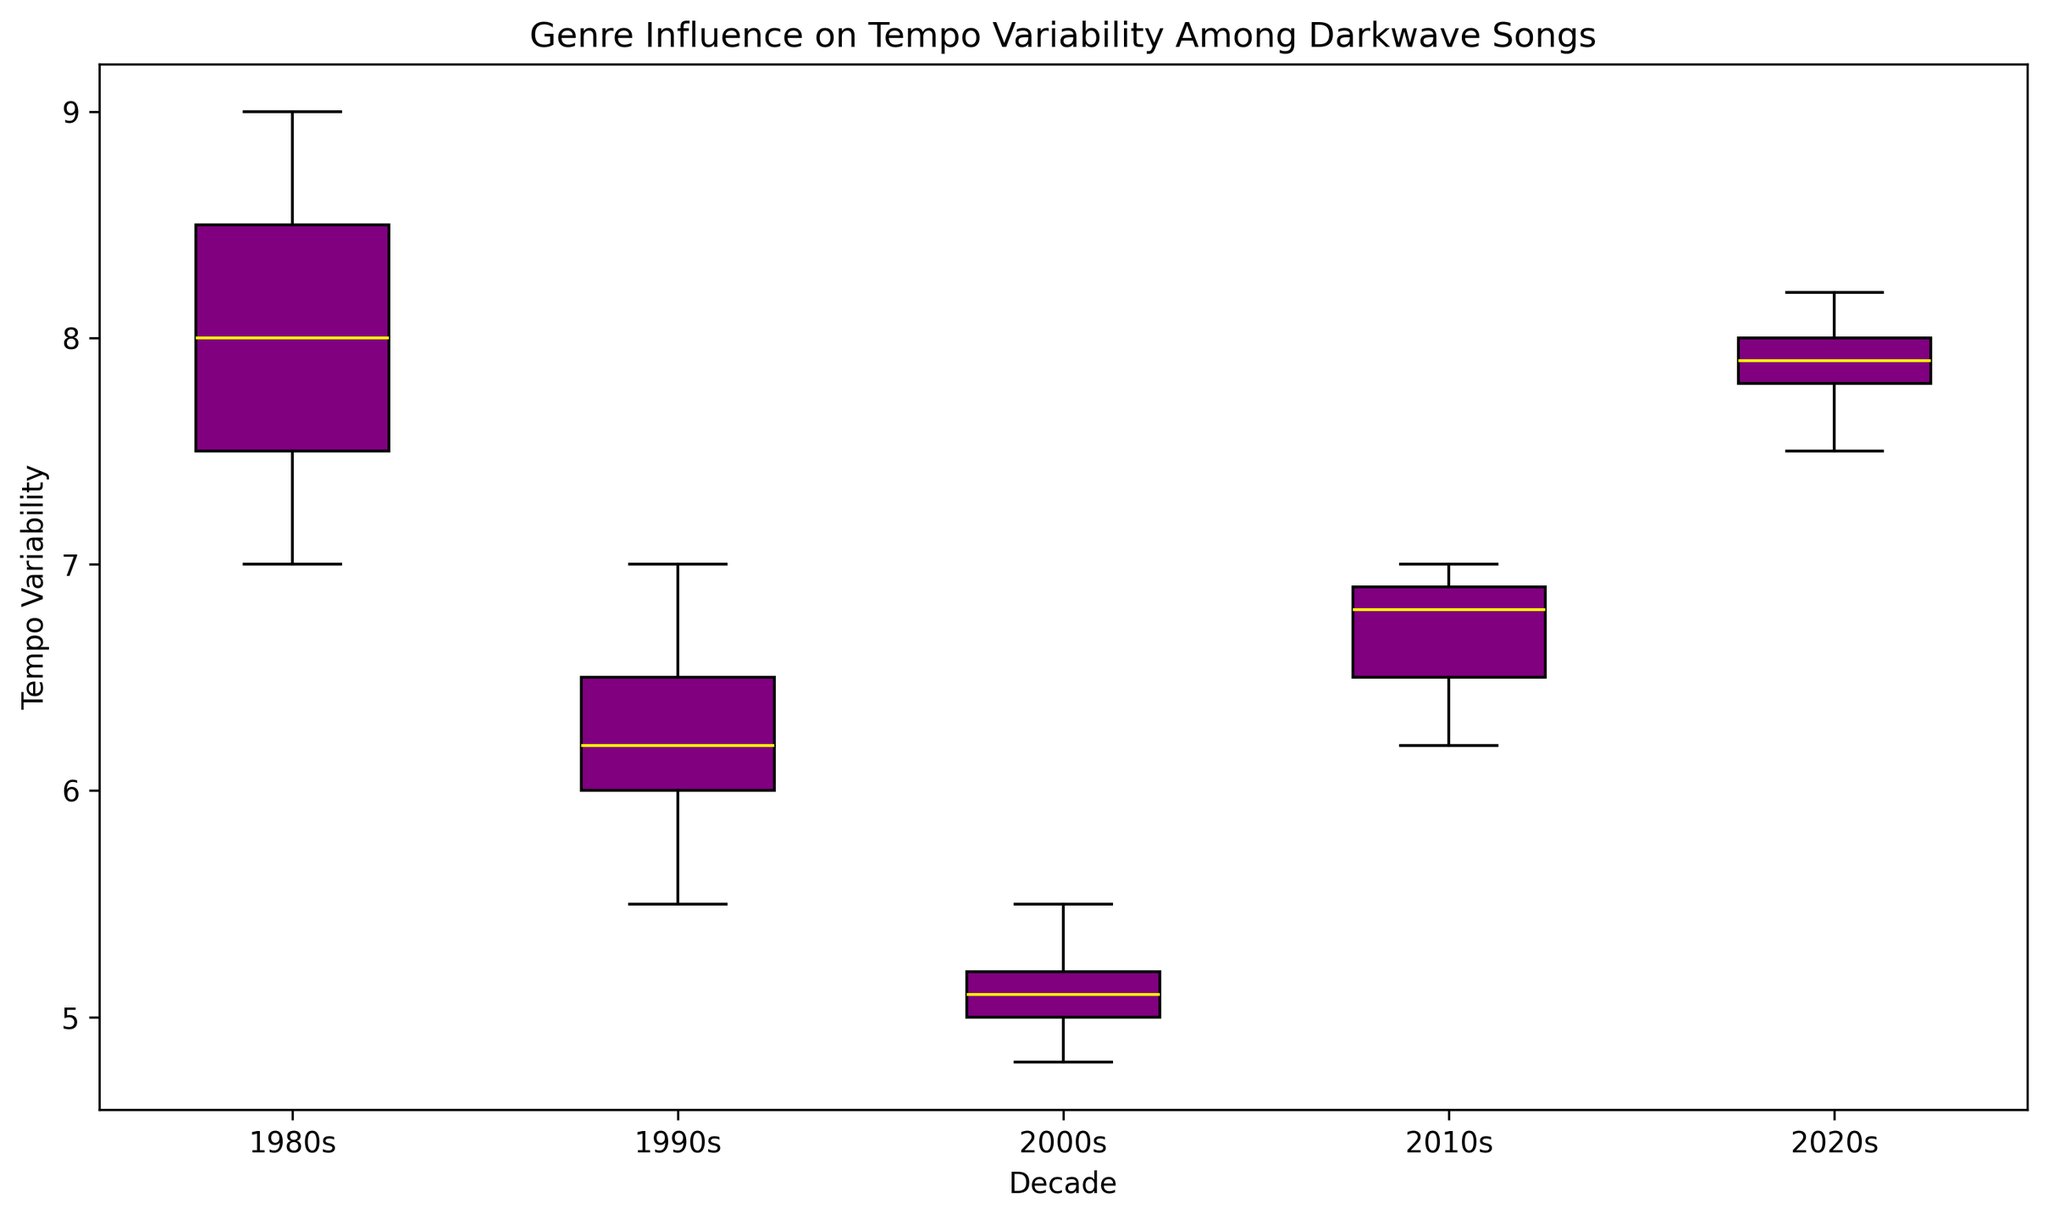What is the median tempo variability for Darkwave songs in the 1980s? The median is the middle value when the data is arranged in ascending order. For the 1980s data points (7, 7.5, 8, 8, 8.5, 9), the median is the average of the middle two values, 8 and 8, which is (8+8)/2.
Answer: 8 Which decade has the highest median tempo variability? To determine the decade with the highest median tempo variability, compare the median values: 1980s (8), 1990s (6), 2000s (5), 2010s (6.8), 2020s (7.8). The highest among them is the 1980s with a median of 8.
Answer: 1980s How does the tempo variability in the 1990s compare to the 2000s? Compare both the median and quartile ranges: The median for the 1990s is 6, and for the 2000s, it is 5. Additionally, the range between the first and third quartile for the 1990s is wider than that of the 2000s, indicating 1990s have higher tempo variability.
Answer: 1990s are higher What color is used to represent the box plot of tempo variability? The box plot sections are represented in purple.
Answer: Purple Which decade shows the most variability in tempo variability, based on the range of the boxes and whiskers? The decade with the largest range of variability would have the tallest boxes and longest whiskers. On inspecting the plot, the 1980s and 2020s both seem to have significant ranges, but the 1980s appears slightly more spread out.
Answer: 1980s What is the lower whisker value for the Darkwave songs' tempo variability in the 2000s? The lower whisker represents the smallest data value that is not an outlier. In the 2000s, it appears to be around 4.8.
Answer: 4.8 Do any decades have outliers in their tempo variability? Check for data points that lie outside the whiskers of the box plot. Upon inspection, no data points appear outside the whiskers in any decade, indicating no outliers.
Answer: No How does the median tempo variability of the 2010s compare to that of the 2020s? Compare the median line within the box plots of each decade. The median for the 2010s is about 6.8, while for the 2020s it's about 7.8.
Answer: The 2020s are higher What is the average of the median tempo variability of the 1980s, 1990s, and 2000s? Calculate the sum of the median values of the three decades and divide by 3. The medians are 8 (1980s), 6 (1990s), and 5 (2000s). Sum them up (8+6+5) and divide by 3 to get (19/3).
Answer: 6.33 How much difference is there between the upper quartile value of the 1990s and the 2000s? The upper quartile (75th percentile) is the top edge of the box. The upper quartile for the 1990s is about 6.5, and for the 2000s, it is about 5.2. The difference is 6.5 - 5.2.
Answer: 1.3 